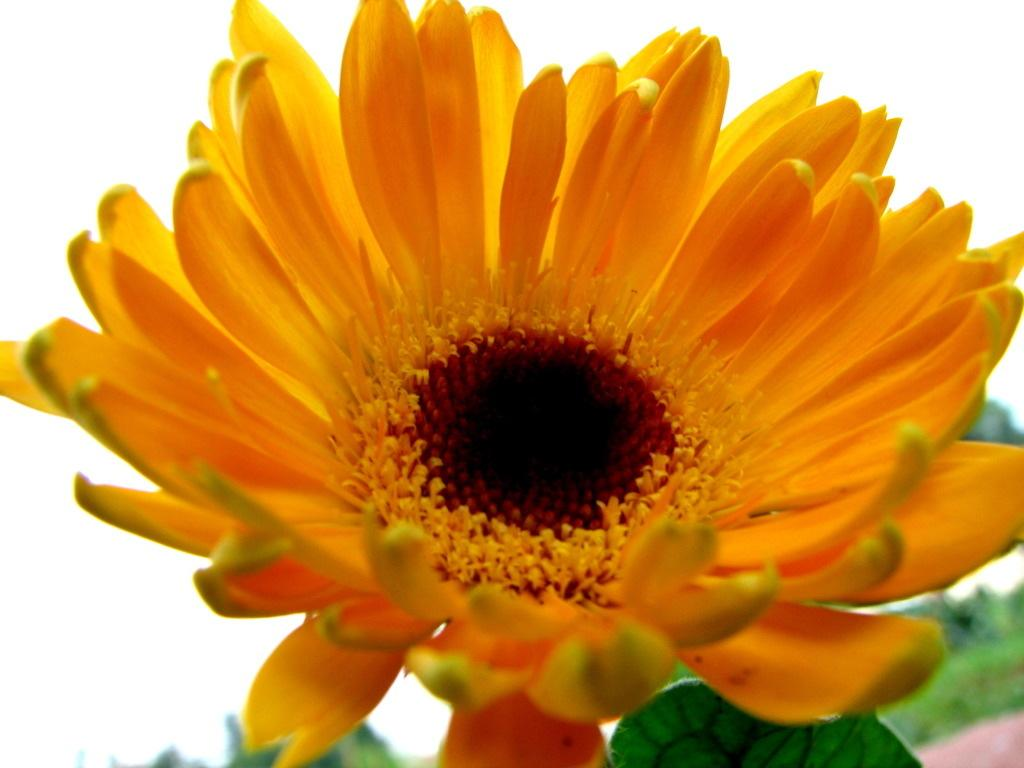What type of plant can be seen in the image? There is a flower in the image. What else is present on the plant besides the flower? There are leaves in the image. Where is the crown placed on the flower in the image? There is no crown present on the flower in the image. 